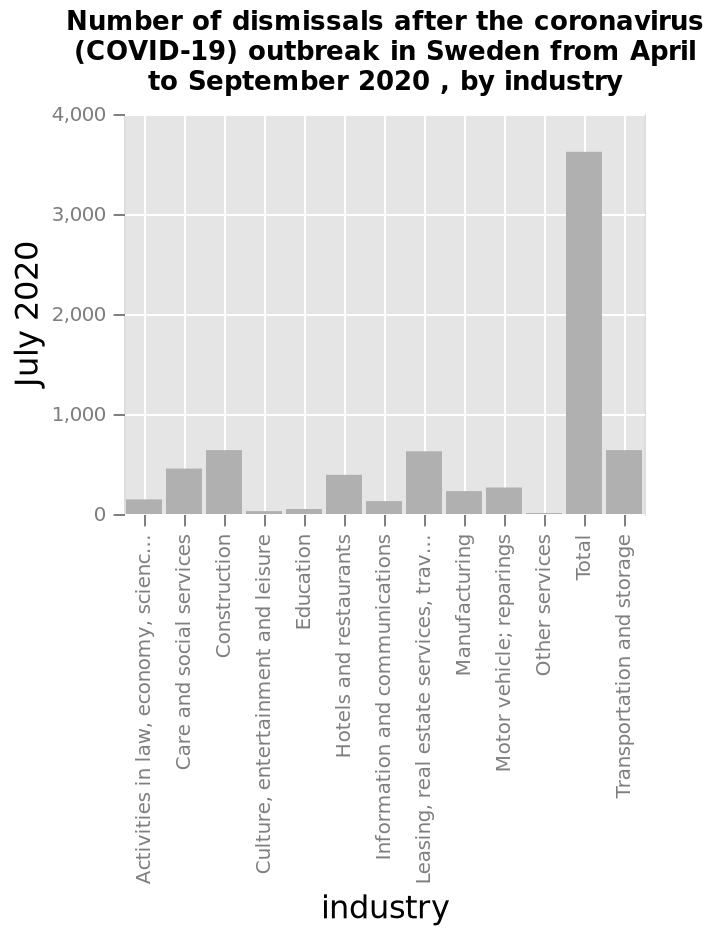<image>
How many industries have a dismissal number over 800? No single industry has a dismissal number over 800. 